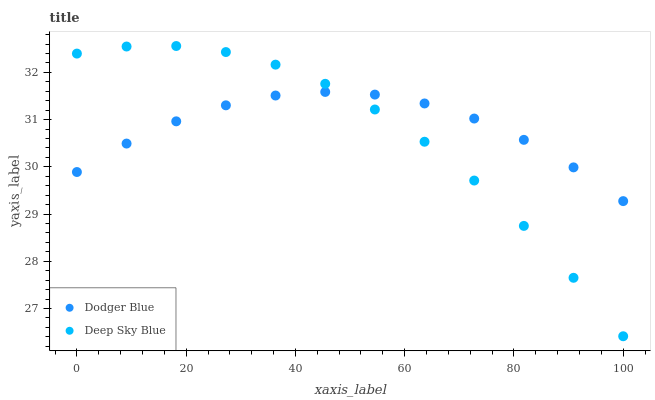Does Deep Sky Blue have the minimum area under the curve?
Answer yes or no. Yes. Does Dodger Blue have the maximum area under the curve?
Answer yes or no. Yes. Does Deep Sky Blue have the maximum area under the curve?
Answer yes or no. No. Is Dodger Blue the smoothest?
Answer yes or no. Yes. Is Deep Sky Blue the roughest?
Answer yes or no. Yes. Is Deep Sky Blue the smoothest?
Answer yes or no. No. Does Deep Sky Blue have the lowest value?
Answer yes or no. Yes. Does Deep Sky Blue have the highest value?
Answer yes or no. Yes. Does Deep Sky Blue intersect Dodger Blue?
Answer yes or no. Yes. Is Deep Sky Blue less than Dodger Blue?
Answer yes or no. No. Is Deep Sky Blue greater than Dodger Blue?
Answer yes or no. No. 